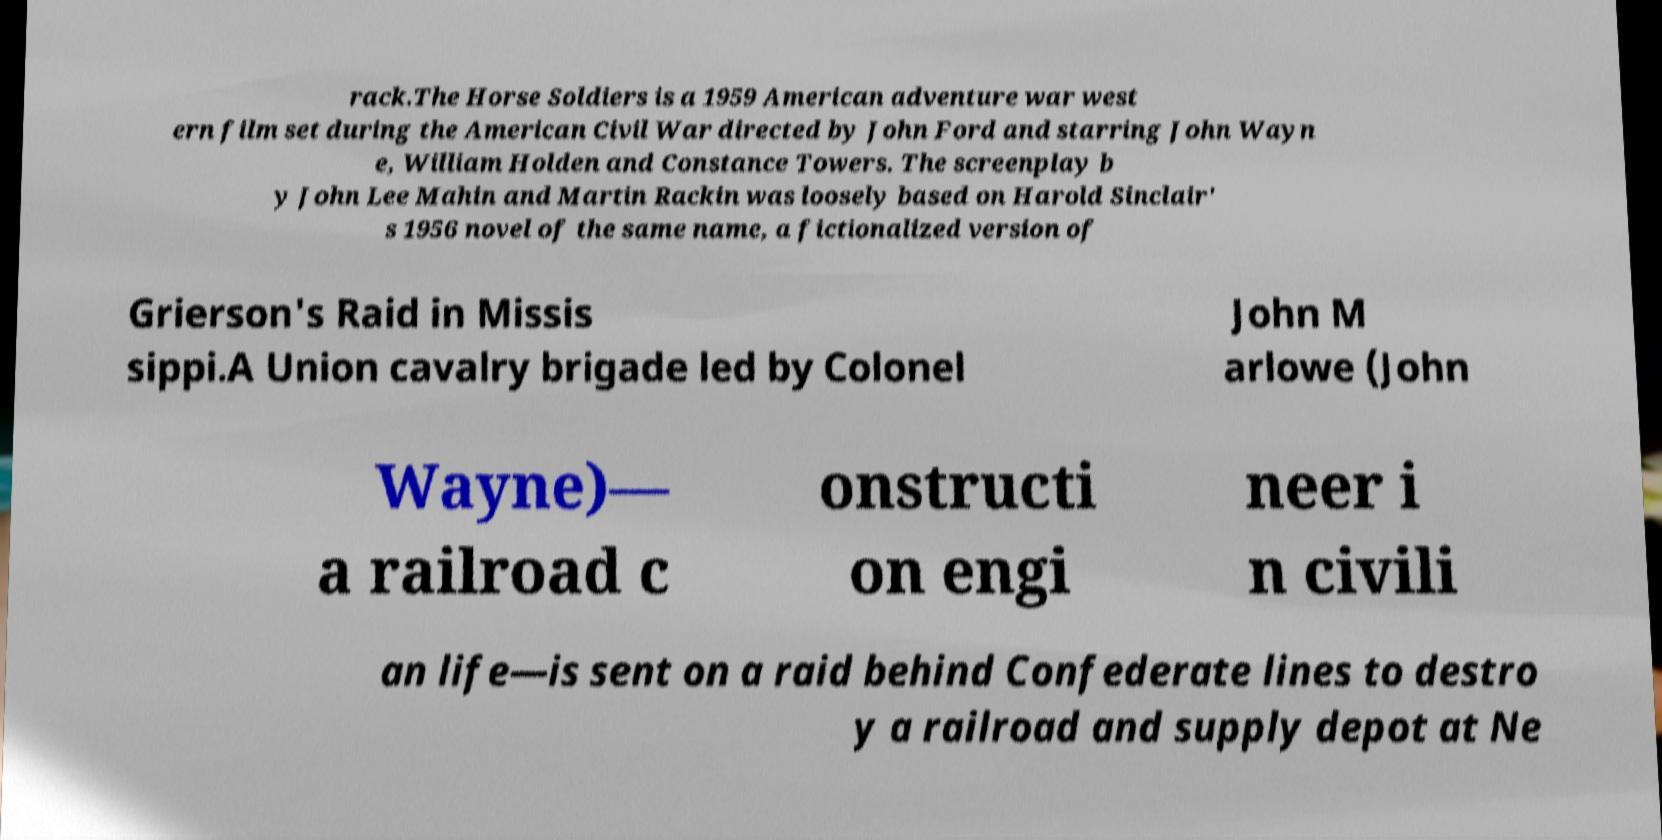There's text embedded in this image that I need extracted. Can you transcribe it verbatim? rack.The Horse Soldiers is a 1959 American adventure war west ern film set during the American Civil War directed by John Ford and starring John Wayn e, William Holden and Constance Towers. The screenplay b y John Lee Mahin and Martin Rackin was loosely based on Harold Sinclair' s 1956 novel of the same name, a fictionalized version of Grierson's Raid in Missis sippi.A Union cavalry brigade led by Colonel John M arlowe (John Wayne)— a railroad c onstructi on engi neer i n civili an life—is sent on a raid behind Confederate lines to destro y a railroad and supply depot at Ne 